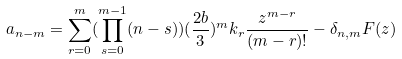Convert formula to latex. <formula><loc_0><loc_0><loc_500><loc_500>a _ { n - m } = \sum _ { r = 0 } ^ { m } ( \prod _ { s = 0 } ^ { m - 1 } ( n - s ) ) ( \frac { 2 b } { 3 } ) ^ { m } k _ { r } \frac { z ^ { m - r } } { ( m - r ) ! } - \delta _ { n , m } F ( z )</formula> 